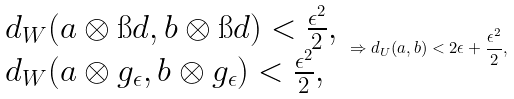Convert formula to latex. <formula><loc_0><loc_0><loc_500><loc_500>\begin{array} { l } d _ { W } ( a \otimes \i d , b \otimes \i d ) < \frac { \epsilon ^ { 2 } } { 2 } , \\ d _ { W } ( a \otimes g _ { \epsilon } , b \otimes g _ { \epsilon } ) < \frac { \epsilon ^ { 2 } } { 2 } , \end{array} \Rightarrow d _ { U } ( a , b ) < 2 \epsilon + \frac { \epsilon ^ { 2 } } { 2 } ,</formula> 